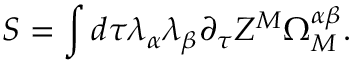<formula> <loc_0><loc_0><loc_500><loc_500>S = \int d \tau \lambda _ { \alpha } \lambda _ { \beta } \partial _ { \tau } Z ^ { M } \Omega _ { M } ^ { \alpha \beta } .</formula> 